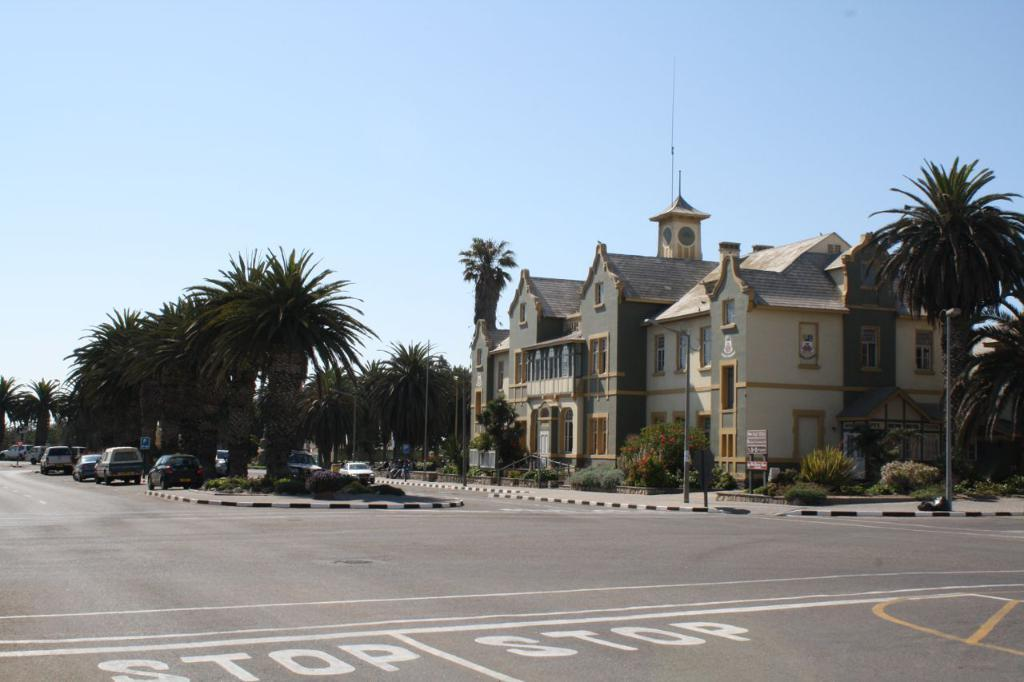What type of structure is present in the image? There is a building in the image. How is the building positioned in relation to the surrounding environment? The building is situated between trees. What else can be seen on the ground in the image? There are cars on the road in the image. What is visible in the background of the image? The sky is visible in the background of the image. Where are the scissors located in the image? There are no scissors present in the image. How much does the dime cost in the image? There is no dime present in the image, so its cost cannot be determined. 